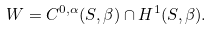<formula> <loc_0><loc_0><loc_500><loc_500>W = C ^ { 0 , \alpha } ( S , \beta ) \cap H ^ { 1 } ( S , \beta ) .</formula> 